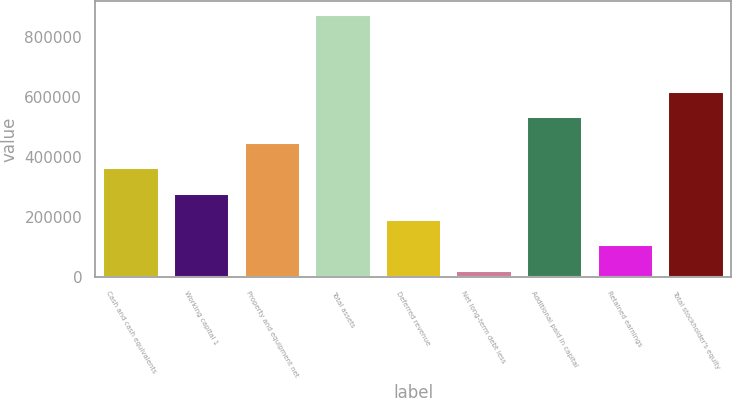Convert chart to OTSL. <chart><loc_0><loc_0><loc_500><loc_500><bar_chart><fcel>Cash and cash equivalents<fcel>Working capital 1<fcel>Property and equipment net<fcel>Total assets<fcel>Deferred revenue<fcel>Net long-term debt less<fcel>Additional paid in capital<fcel>Retained earnings<fcel>Total stockholder's equity<nl><fcel>365576<fcel>280396<fcel>450756<fcel>876655<fcel>195216<fcel>24856<fcel>535935<fcel>110036<fcel>621115<nl></chart> 